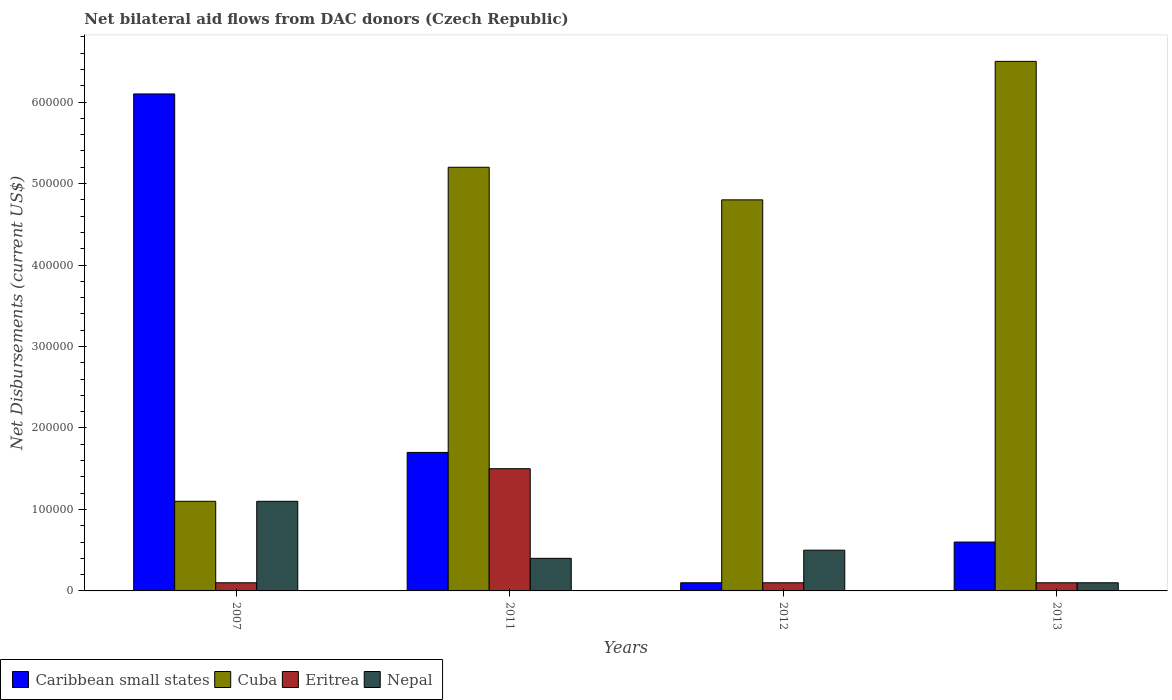How many groups of bars are there?
Provide a short and direct response. 4. Are the number of bars on each tick of the X-axis equal?
Keep it short and to the point. Yes. How many bars are there on the 2nd tick from the right?
Your response must be concise. 4. What is the label of the 1st group of bars from the left?
Your answer should be compact. 2007. Across all years, what is the maximum net bilateral aid flows in Eritrea?
Your answer should be compact. 1.50e+05. Across all years, what is the minimum net bilateral aid flows in Eritrea?
Keep it short and to the point. 10000. In which year was the net bilateral aid flows in Eritrea maximum?
Give a very brief answer. 2011. What is the total net bilateral aid flows in Caribbean small states in the graph?
Your answer should be compact. 8.50e+05. What is the difference between the net bilateral aid flows in Nepal in 2007 and that in 2011?
Your answer should be very brief. 7.00e+04. What is the average net bilateral aid flows in Eritrea per year?
Your response must be concise. 4.50e+04. In the year 2007, what is the difference between the net bilateral aid flows in Eritrea and net bilateral aid flows in Cuba?
Give a very brief answer. -1.00e+05. What is the ratio of the net bilateral aid flows in Eritrea in 2011 to that in 2012?
Keep it short and to the point. 15. What is the difference between the highest and the lowest net bilateral aid flows in Cuba?
Provide a succinct answer. 5.40e+05. In how many years, is the net bilateral aid flows in Cuba greater than the average net bilateral aid flows in Cuba taken over all years?
Your answer should be very brief. 3. What does the 3rd bar from the left in 2013 represents?
Offer a terse response. Eritrea. What does the 2nd bar from the right in 2007 represents?
Make the answer very short. Eritrea. Are all the bars in the graph horizontal?
Ensure brevity in your answer.  No. What is the difference between two consecutive major ticks on the Y-axis?
Keep it short and to the point. 1.00e+05. Does the graph contain grids?
Provide a succinct answer. No. How are the legend labels stacked?
Your answer should be very brief. Horizontal. What is the title of the graph?
Keep it short and to the point. Net bilateral aid flows from DAC donors (Czech Republic). What is the label or title of the Y-axis?
Make the answer very short. Net Disbursements (current US$). What is the Net Disbursements (current US$) in Nepal in 2007?
Offer a terse response. 1.10e+05. What is the Net Disbursements (current US$) in Caribbean small states in 2011?
Your answer should be compact. 1.70e+05. What is the Net Disbursements (current US$) in Cuba in 2011?
Ensure brevity in your answer.  5.20e+05. What is the Net Disbursements (current US$) in Cuba in 2013?
Provide a succinct answer. 6.50e+05. Across all years, what is the maximum Net Disbursements (current US$) in Cuba?
Offer a very short reply. 6.50e+05. Across all years, what is the maximum Net Disbursements (current US$) of Eritrea?
Give a very brief answer. 1.50e+05. Across all years, what is the maximum Net Disbursements (current US$) in Nepal?
Your answer should be compact. 1.10e+05. Across all years, what is the minimum Net Disbursements (current US$) of Caribbean small states?
Your answer should be very brief. 10000. Across all years, what is the minimum Net Disbursements (current US$) of Cuba?
Provide a short and direct response. 1.10e+05. Across all years, what is the minimum Net Disbursements (current US$) of Nepal?
Your response must be concise. 10000. What is the total Net Disbursements (current US$) in Caribbean small states in the graph?
Give a very brief answer. 8.50e+05. What is the total Net Disbursements (current US$) of Cuba in the graph?
Your answer should be very brief. 1.76e+06. What is the total Net Disbursements (current US$) in Eritrea in the graph?
Offer a very short reply. 1.80e+05. What is the total Net Disbursements (current US$) in Nepal in the graph?
Your response must be concise. 2.10e+05. What is the difference between the Net Disbursements (current US$) in Caribbean small states in 2007 and that in 2011?
Provide a short and direct response. 4.40e+05. What is the difference between the Net Disbursements (current US$) of Cuba in 2007 and that in 2011?
Your answer should be very brief. -4.10e+05. What is the difference between the Net Disbursements (current US$) of Eritrea in 2007 and that in 2011?
Provide a short and direct response. -1.40e+05. What is the difference between the Net Disbursements (current US$) in Nepal in 2007 and that in 2011?
Ensure brevity in your answer.  7.00e+04. What is the difference between the Net Disbursements (current US$) in Cuba in 2007 and that in 2012?
Your answer should be very brief. -3.70e+05. What is the difference between the Net Disbursements (current US$) in Eritrea in 2007 and that in 2012?
Your answer should be compact. 0. What is the difference between the Net Disbursements (current US$) of Nepal in 2007 and that in 2012?
Offer a terse response. 6.00e+04. What is the difference between the Net Disbursements (current US$) in Caribbean small states in 2007 and that in 2013?
Offer a terse response. 5.50e+05. What is the difference between the Net Disbursements (current US$) in Cuba in 2007 and that in 2013?
Provide a short and direct response. -5.40e+05. What is the difference between the Net Disbursements (current US$) of Eritrea in 2007 and that in 2013?
Your response must be concise. 0. What is the difference between the Net Disbursements (current US$) in Nepal in 2007 and that in 2013?
Give a very brief answer. 1.00e+05. What is the difference between the Net Disbursements (current US$) in Cuba in 2011 and that in 2012?
Ensure brevity in your answer.  4.00e+04. What is the difference between the Net Disbursements (current US$) of Caribbean small states in 2011 and that in 2013?
Keep it short and to the point. 1.10e+05. What is the difference between the Net Disbursements (current US$) of Cuba in 2011 and that in 2013?
Your answer should be compact. -1.30e+05. What is the difference between the Net Disbursements (current US$) in Nepal in 2011 and that in 2013?
Give a very brief answer. 3.00e+04. What is the difference between the Net Disbursements (current US$) in Cuba in 2012 and that in 2013?
Provide a succinct answer. -1.70e+05. What is the difference between the Net Disbursements (current US$) of Eritrea in 2012 and that in 2013?
Keep it short and to the point. 0. What is the difference between the Net Disbursements (current US$) in Nepal in 2012 and that in 2013?
Provide a short and direct response. 4.00e+04. What is the difference between the Net Disbursements (current US$) of Caribbean small states in 2007 and the Net Disbursements (current US$) of Cuba in 2011?
Your answer should be very brief. 9.00e+04. What is the difference between the Net Disbursements (current US$) of Caribbean small states in 2007 and the Net Disbursements (current US$) of Eritrea in 2011?
Provide a succinct answer. 4.60e+05. What is the difference between the Net Disbursements (current US$) in Caribbean small states in 2007 and the Net Disbursements (current US$) in Nepal in 2011?
Offer a terse response. 5.70e+05. What is the difference between the Net Disbursements (current US$) of Cuba in 2007 and the Net Disbursements (current US$) of Nepal in 2011?
Provide a succinct answer. 7.00e+04. What is the difference between the Net Disbursements (current US$) in Eritrea in 2007 and the Net Disbursements (current US$) in Nepal in 2011?
Your response must be concise. -3.00e+04. What is the difference between the Net Disbursements (current US$) in Caribbean small states in 2007 and the Net Disbursements (current US$) in Eritrea in 2012?
Provide a short and direct response. 6.00e+05. What is the difference between the Net Disbursements (current US$) of Caribbean small states in 2007 and the Net Disbursements (current US$) of Nepal in 2012?
Your answer should be compact. 5.60e+05. What is the difference between the Net Disbursements (current US$) of Eritrea in 2007 and the Net Disbursements (current US$) of Nepal in 2012?
Keep it short and to the point. -4.00e+04. What is the difference between the Net Disbursements (current US$) of Caribbean small states in 2007 and the Net Disbursements (current US$) of Eritrea in 2013?
Offer a terse response. 6.00e+05. What is the difference between the Net Disbursements (current US$) in Eritrea in 2007 and the Net Disbursements (current US$) in Nepal in 2013?
Your answer should be compact. 0. What is the difference between the Net Disbursements (current US$) in Caribbean small states in 2011 and the Net Disbursements (current US$) in Cuba in 2012?
Offer a very short reply. -3.10e+05. What is the difference between the Net Disbursements (current US$) in Caribbean small states in 2011 and the Net Disbursements (current US$) in Nepal in 2012?
Keep it short and to the point. 1.20e+05. What is the difference between the Net Disbursements (current US$) in Cuba in 2011 and the Net Disbursements (current US$) in Eritrea in 2012?
Make the answer very short. 5.10e+05. What is the difference between the Net Disbursements (current US$) of Cuba in 2011 and the Net Disbursements (current US$) of Nepal in 2012?
Offer a very short reply. 4.70e+05. What is the difference between the Net Disbursements (current US$) in Eritrea in 2011 and the Net Disbursements (current US$) in Nepal in 2012?
Keep it short and to the point. 1.00e+05. What is the difference between the Net Disbursements (current US$) of Caribbean small states in 2011 and the Net Disbursements (current US$) of Cuba in 2013?
Your response must be concise. -4.80e+05. What is the difference between the Net Disbursements (current US$) in Caribbean small states in 2011 and the Net Disbursements (current US$) in Nepal in 2013?
Provide a succinct answer. 1.60e+05. What is the difference between the Net Disbursements (current US$) of Cuba in 2011 and the Net Disbursements (current US$) of Eritrea in 2013?
Your response must be concise. 5.10e+05. What is the difference between the Net Disbursements (current US$) of Cuba in 2011 and the Net Disbursements (current US$) of Nepal in 2013?
Provide a succinct answer. 5.10e+05. What is the difference between the Net Disbursements (current US$) in Caribbean small states in 2012 and the Net Disbursements (current US$) in Cuba in 2013?
Offer a terse response. -6.40e+05. What is the difference between the Net Disbursements (current US$) in Caribbean small states in 2012 and the Net Disbursements (current US$) in Eritrea in 2013?
Ensure brevity in your answer.  0. What is the difference between the Net Disbursements (current US$) in Caribbean small states in 2012 and the Net Disbursements (current US$) in Nepal in 2013?
Your answer should be compact. 0. What is the difference between the Net Disbursements (current US$) of Cuba in 2012 and the Net Disbursements (current US$) of Eritrea in 2013?
Make the answer very short. 4.70e+05. What is the difference between the Net Disbursements (current US$) in Eritrea in 2012 and the Net Disbursements (current US$) in Nepal in 2013?
Give a very brief answer. 0. What is the average Net Disbursements (current US$) in Caribbean small states per year?
Your response must be concise. 2.12e+05. What is the average Net Disbursements (current US$) of Eritrea per year?
Provide a succinct answer. 4.50e+04. What is the average Net Disbursements (current US$) in Nepal per year?
Offer a very short reply. 5.25e+04. In the year 2011, what is the difference between the Net Disbursements (current US$) in Caribbean small states and Net Disbursements (current US$) in Cuba?
Ensure brevity in your answer.  -3.50e+05. In the year 2011, what is the difference between the Net Disbursements (current US$) in Caribbean small states and Net Disbursements (current US$) in Nepal?
Provide a succinct answer. 1.30e+05. In the year 2011, what is the difference between the Net Disbursements (current US$) of Eritrea and Net Disbursements (current US$) of Nepal?
Make the answer very short. 1.10e+05. In the year 2012, what is the difference between the Net Disbursements (current US$) in Caribbean small states and Net Disbursements (current US$) in Cuba?
Make the answer very short. -4.70e+05. In the year 2012, what is the difference between the Net Disbursements (current US$) in Cuba and Net Disbursements (current US$) in Nepal?
Give a very brief answer. 4.30e+05. In the year 2013, what is the difference between the Net Disbursements (current US$) in Caribbean small states and Net Disbursements (current US$) in Cuba?
Offer a terse response. -5.90e+05. In the year 2013, what is the difference between the Net Disbursements (current US$) of Caribbean small states and Net Disbursements (current US$) of Nepal?
Give a very brief answer. 5.00e+04. In the year 2013, what is the difference between the Net Disbursements (current US$) of Cuba and Net Disbursements (current US$) of Eritrea?
Make the answer very short. 6.40e+05. In the year 2013, what is the difference between the Net Disbursements (current US$) in Cuba and Net Disbursements (current US$) in Nepal?
Keep it short and to the point. 6.40e+05. What is the ratio of the Net Disbursements (current US$) in Caribbean small states in 2007 to that in 2011?
Your answer should be very brief. 3.59. What is the ratio of the Net Disbursements (current US$) of Cuba in 2007 to that in 2011?
Provide a short and direct response. 0.21. What is the ratio of the Net Disbursements (current US$) in Eritrea in 2007 to that in 2011?
Provide a succinct answer. 0.07. What is the ratio of the Net Disbursements (current US$) of Nepal in 2007 to that in 2011?
Your response must be concise. 2.75. What is the ratio of the Net Disbursements (current US$) in Caribbean small states in 2007 to that in 2012?
Your response must be concise. 61. What is the ratio of the Net Disbursements (current US$) of Cuba in 2007 to that in 2012?
Keep it short and to the point. 0.23. What is the ratio of the Net Disbursements (current US$) in Nepal in 2007 to that in 2012?
Keep it short and to the point. 2.2. What is the ratio of the Net Disbursements (current US$) in Caribbean small states in 2007 to that in 2013?
Provide a short and direct response. 10.17. What is the ratio of the Net Disbursements (current US$) of Cuba in 2007 to that in 2013?
Provide a short and direct response. 0.17. What is the ratio of the Net Disbursements (current US$) of Nepal in 2007 to that in 2013?
Make the answer very short. 11. What is the ratio of the Net Disbursements (current US$) of Caribbean small states in 2011 to that in 2012?
Your answer should be compact. 17. What is the ratio of the Net Disbursements (current US$) in Eritrea in 2011 to that in 2012?
Your response must be concise. 15. What is the ratio of the Net Disbursements (current US$) of Caribbean small states in 2011 to that in 2013?
Provide a short and direct response. 2.83. What is the ratio of the Net Disbursements (current US$) in Eritrea in 2011 to that in 2013?
Ensure brevity in your answer.  15. What is the ratio of the Net Disbursements (current US$) in Caribbean small states in 2012 to that in 2013?
Offer a very short reply. 0.17. What is the ratio of the Net Disbursements (current US$) in Cuba in 2012 to that in 2013?
Ensure brevity in your answer.  0.74. What is the ratio of the Net Disbursements (current US$) of Eritrea in 2012 to that in 2013?
Keep it short and to the point. 1. What is the ratio of the Net Disbursements (current US$) in Nepal in 2012 to that in 2013?
Offer a terse response. 5. What is the difference between the highest and the second highest Net Disbursements (current US$) of Caribbean small states?
Keep it short and to the point. 4.40e+05. What is the difference between the highest and the second highest Net Disbursements (current US$) in Eritrea?
Your answer should be very brief. 1.40e+05. What is the difference between the highest and the lowest Net Disbursements (current US$) of Caribbean small states?
Provide a succinct answer. 6.00e+05. What is the difference between the highest and the lowest Net Disbursements (current US$) of Cuba?
Your response must be concise. 5.40e+05. What is the difference between the highest and the lowest Net Disbursements (current US$) in Eritrea?
Offer a terse response. 1.40e+05. 